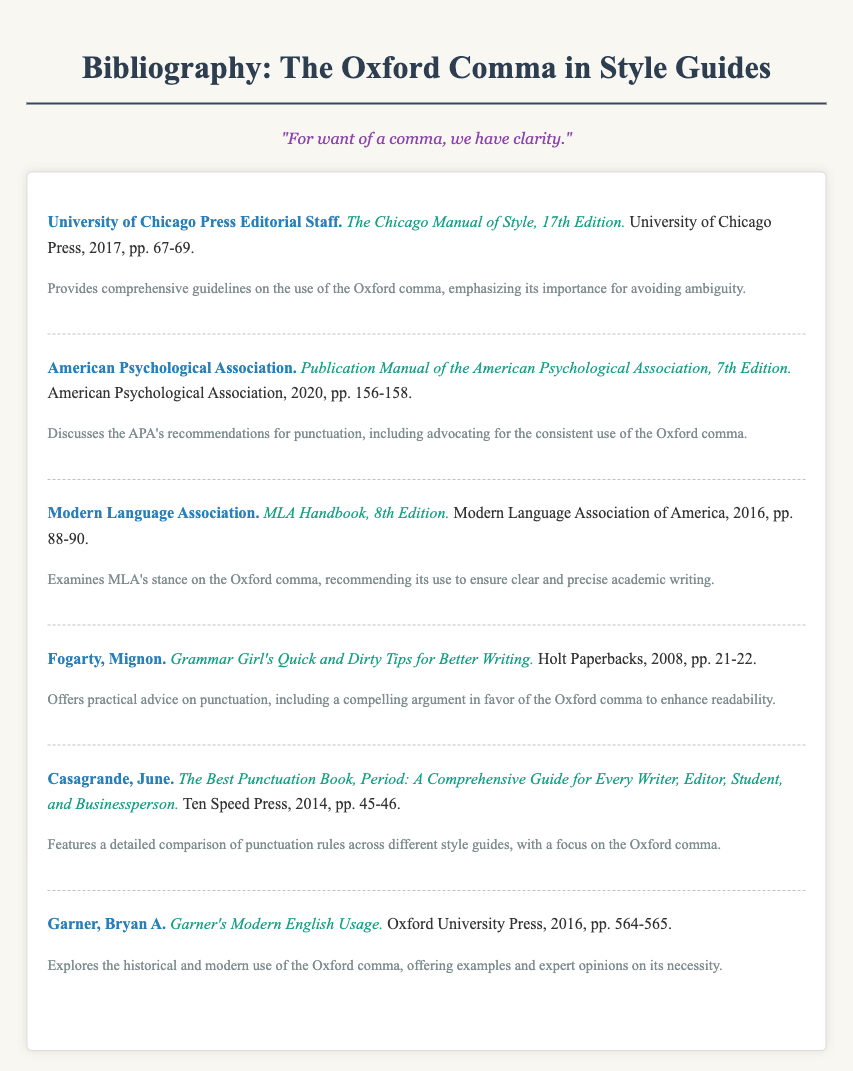What is the title of the first entry in the bibliography? The title of the first entry can be found in the formatted list, which states "The Chicago Manual of Style, 17th Edition."
Answer: The Chicago Manual of Style, 17th Edition Who authored the second entry in the bibliography? The author's name of the second entry is stated at the beginning of the entry as "American Psychological Association."
Answer: American Psychological Association In which year was the MLA Handbook published? The publication year for the MLA Handbook is mentioned in the bibliography entry as 2016.
Answer: 2016 What does the third entry recommend regarding the Oxford comma? The note for the third entry indicates that it recommends the use of the Oxford comma for clear and precise academic writing.
Answer: To ensure clear and precise academic writing How many pages does the Chicago Manual of Style cover regarding the Oxford comma? The bibliography entry states that the discussion on the Oxford comma spans pages 67 to 69, which totals 3 pages.
Answer: 3 pages Which entry provides practical advice on punctuation? The entry that provides practical advice is authored by Mignon Fogarty and titled "Grammar Girl's Quick and Dirty Tips for Better Writing."
Answer: Grammar Girl's Quick and Dirty Tips for Better Writing What is a common theme discussed in all the entries regarding the Oxford comma? The common theme across all entries highlights the importance of the Oxford comma for clarity and avoiding ambiguity.
Answer: Importance for clarity and avoiding ambiguity How many entries are listed in the bibliography? The document contains a total of six entries, each with distinct authors and titles.
Answer: Six entries 